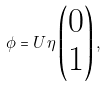<formula> <loc_0><loc_0><loc_500><loc_500>\phi = U \eta \begin{pmatrix} 0 \\ 1 \end{pmatrix} ,</formula> 